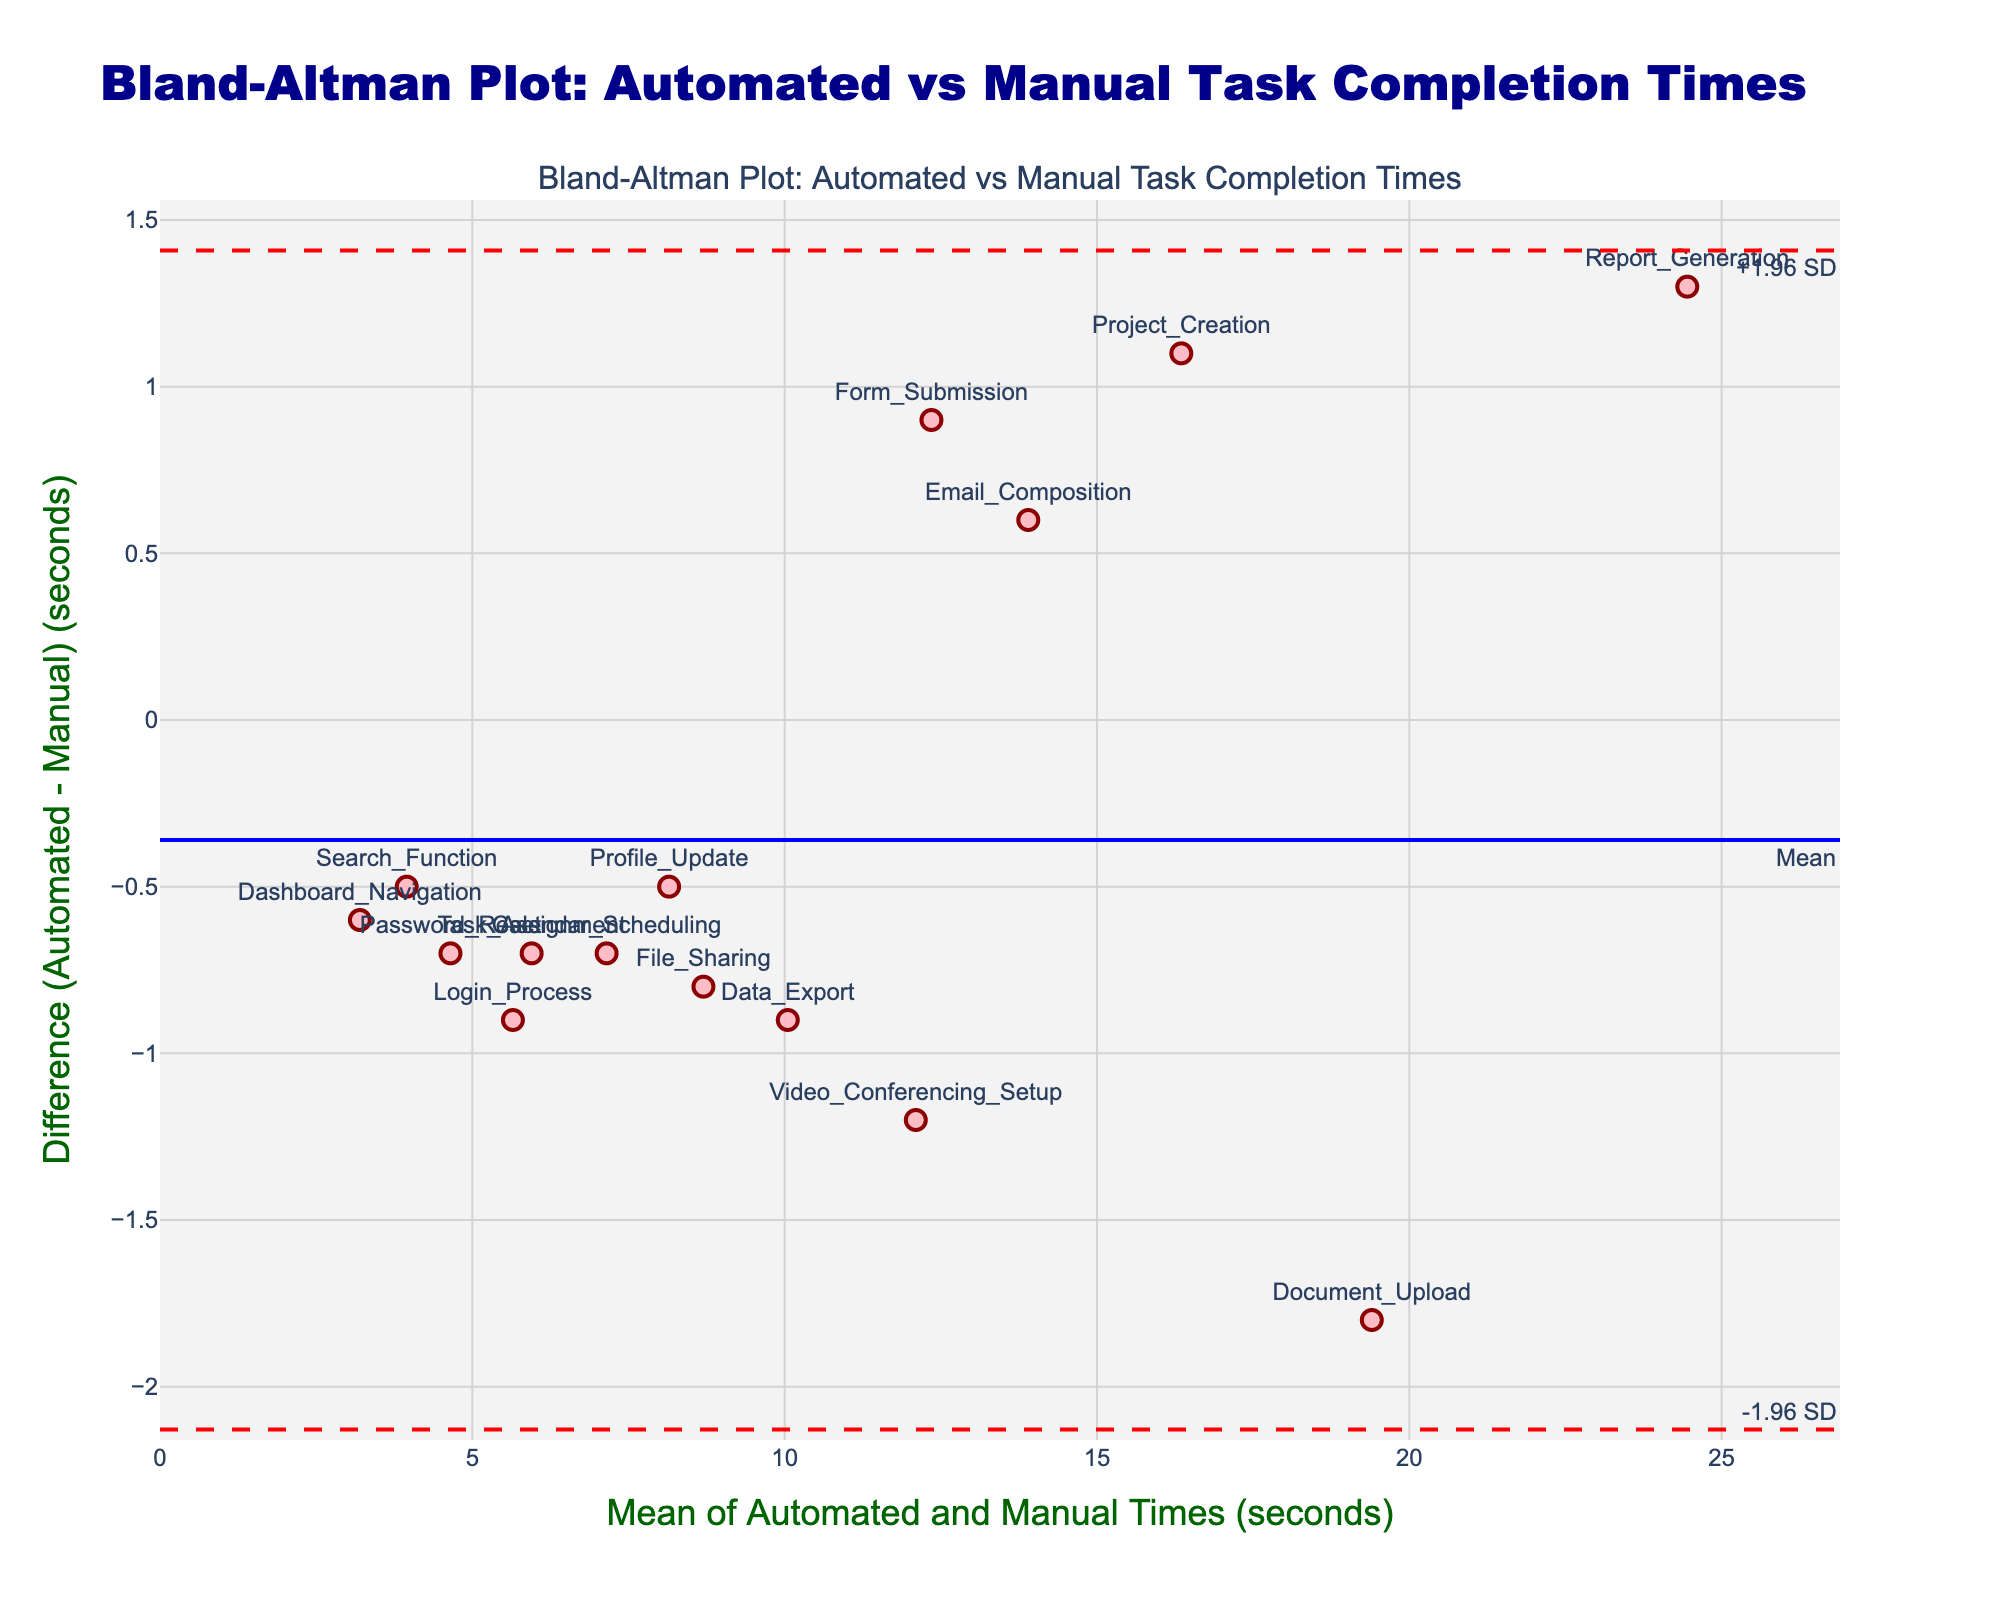What is the title of the plot? The title is usually displayed at the top of the plot. Here, it is "Bland-Altman Plot: Automated vs Manual Task Completion Times," which provides context to what the plot is comparing.
Answer: Bland-Altman Plot: Automated vs Manual Task Completion Times How many data points are plotted in the figure? The data points represent different tasks. By counting the markers in the scatter plot or by checking the data, we see there are 15 tasks in total.
Answer: 15 What is the mean difference between Automated and Manual times? The mean difference is shown by a solid blue line on the plot. It is indicated as being marked as 'Mean' on the plot.
Answer: ~0.13 seconds Which task shows the largest negative difference? The largest negative difference means the Automated time is significantly lower than the Manual time. Locate the lowest point on the y-axis, with the label below it. It corresponds to "Document_Upload."
Answer: Document_Upload What are the values of the limits of agreement (LoA)? The limits of agreement are denoted by the dashed red lines. The values next to these lines generally indicate "-1.96 SD" and "+1.96 SD."
Answer: ~-1.79 and ~2.05 seconds What task has the closest mean task completion time? The mean task completion time can be found by averaging the Automated and Manual times for each task. The task closest to the center on the x-axis is "File Sharing."
Answer: File Sharing What is the range of the x-axis in this plot? The x-axis represents the mean of Automated and Manual times, extended slightly beyond the maximum mean value calculated. It ranges approximately from 0 to around 27.5 seconds.
Answer: ~0 to ~27.5 seconds Which tasks have a positive difference? Positive differences can be found by identifying which markers are above the zero horizontal line. These tasks include "Login_Process," "Report_Generation," "Password_Reset," "Profile_Update," "Email_Composition," "Calendar_Scheduling," "File_Sharing," "Project_Creation," "Task_Assignment."
Answer: Login_Process, Report_Generation, Password_Reset, Profile_Update, Email_Composition, Calendar_Scheduling, File_Sharing, Project_Creation, Task_Assignment How does the "Search_Function" task compare to "Login_Process" in terms of difference? Compare their positions on the y-axis. "Search_Function" has a less negative difference compared to "Login_Process," indicating that the difference for "Search_Function" is smaller.
Answer: Smaller negative difference 